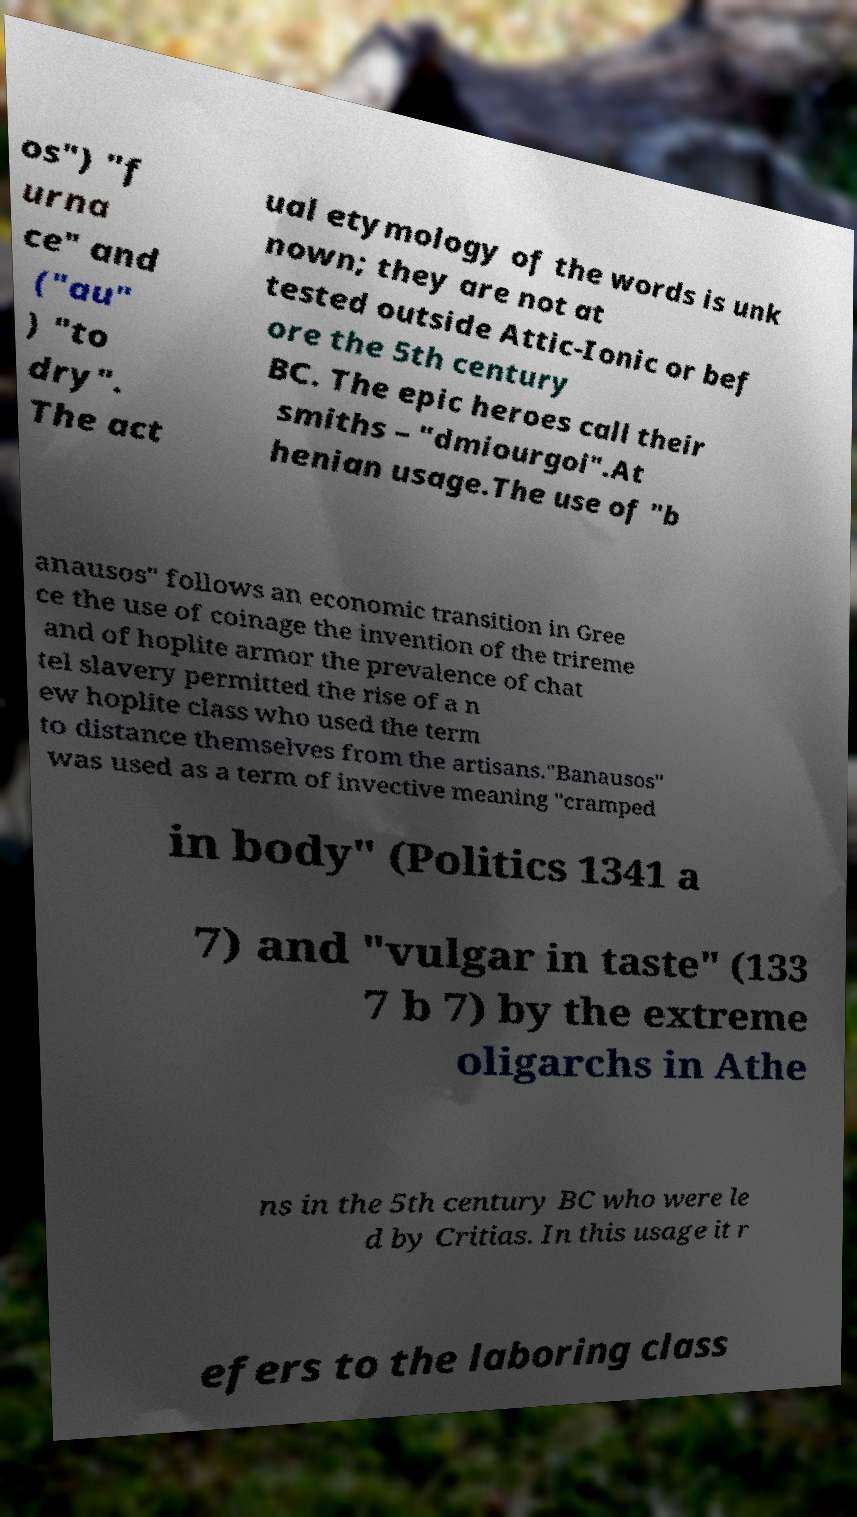Please identify and transcribe the text found in this image. os") "f urna ce" and ("au" ) "to dry". The act ual etymology of the words is unk nown; they are not at tested outside Attic-Ionic or bef ore the 5th century BC. The epic heroes call their smiths – "dmiourgoi".At henian usage.The use of "b anausos" follows an economic transition in Gree ce the use of coinage the invention of the trireme and of hoplite armor the prevalence of chat tel slavery permitted the rise of a n ew hoplite class who used the term to distance themselves from the artisans."Banausos" was used as a term of invective meaning "cramped in body" (Politics 1341 a 7) and "vulgar in taste" (133 7 b 7) by the extreme oligarchs in Athe ns in the 5th century BC who were le d by Critias. In this usage it r efers to the laboring class 